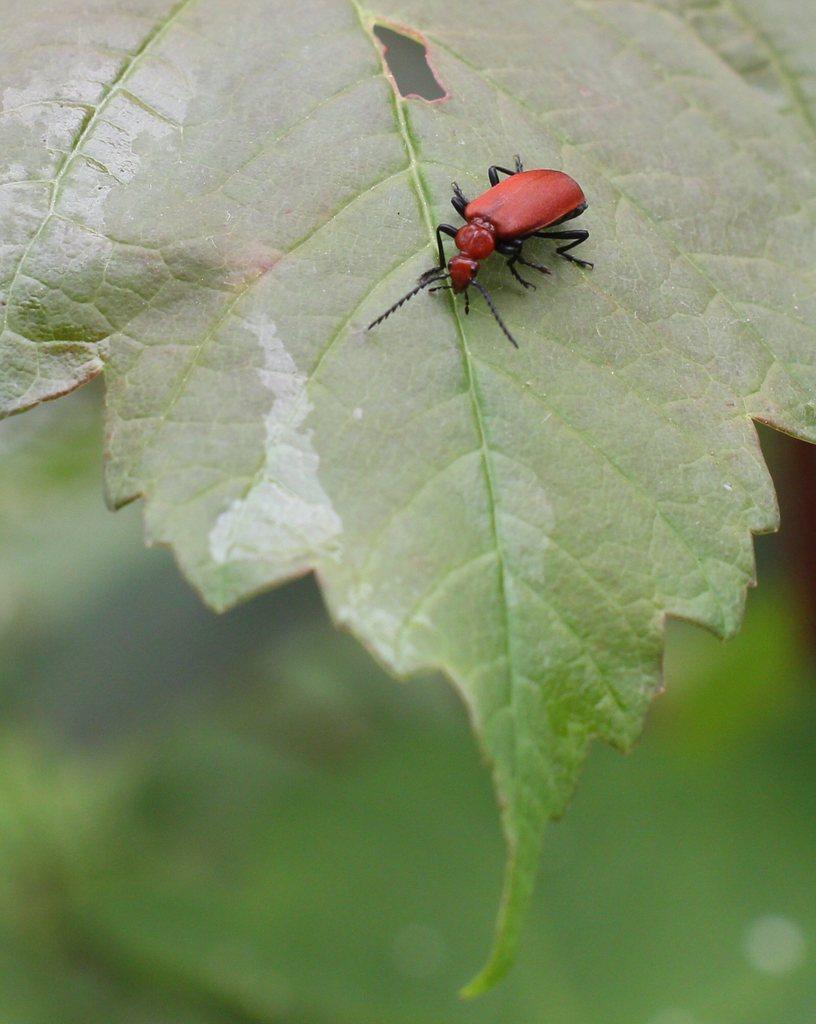How would you summarize this image in a sentence or two? In this picture I can see an insect on the leaf, and there is blur background. 